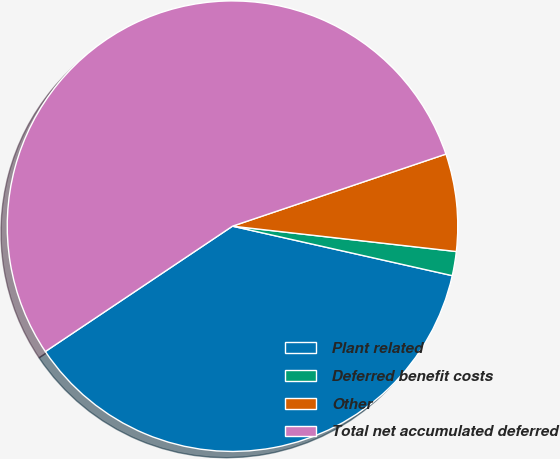<chart> <loc_0><loc_0><loc_500><loc_500><pie_chart><fcel>Plant related<fcel>Deferred benefit costs<fcel>Other<fcel>Total net accumulated deferred<nl><fcel>37.08%<fcel>1.73%<fcel>6.98%<fcel>54.21%<nl></chart> 